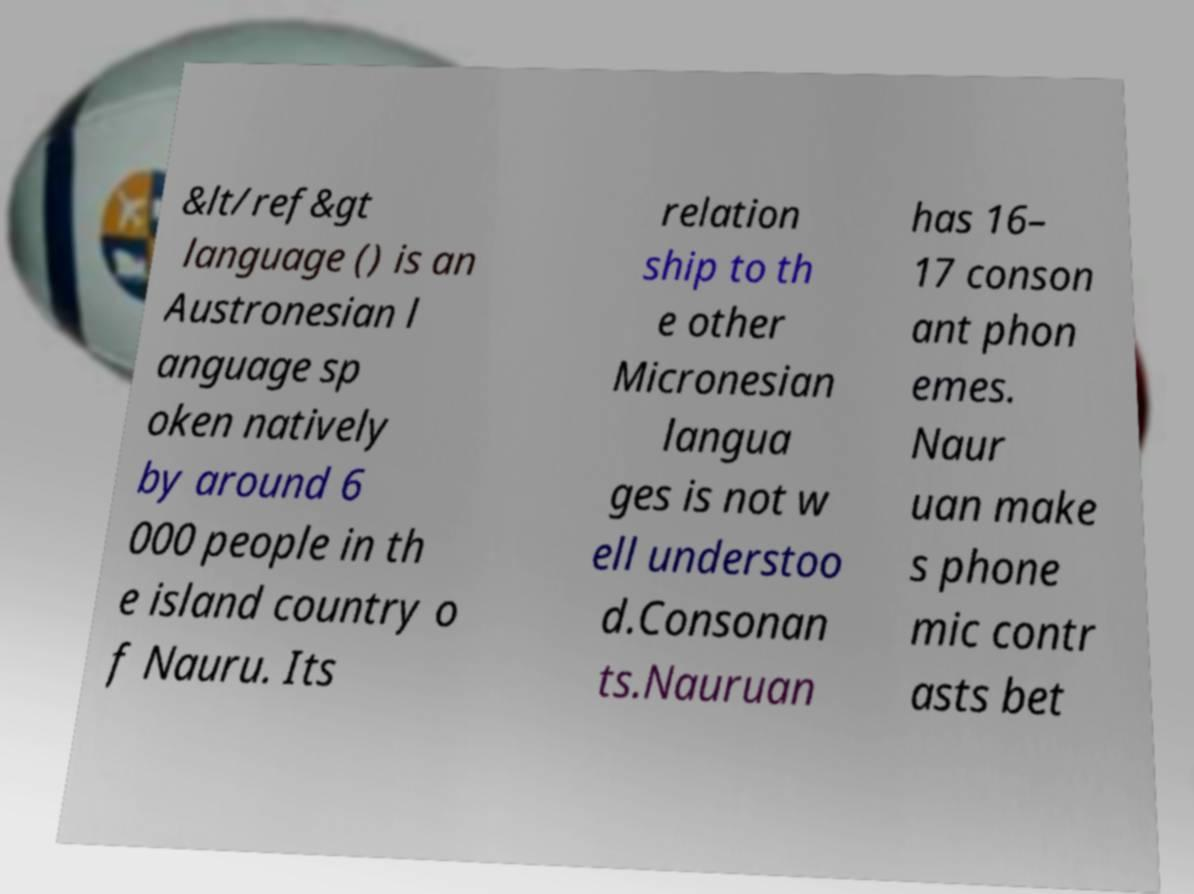Please identify and transcribe the text found in this image. &lt/ref&gt language () is an Austronesian l anguage sp oken natively by around 6 000 people in th e island country o f Nauru. Its relation ship to th e other Micronesian langua ges is not w ell understoo d.Consonan ts.Nauruan has 16– 17 conson ant phon emes. Naur uan make s phone mic contr asts bet 